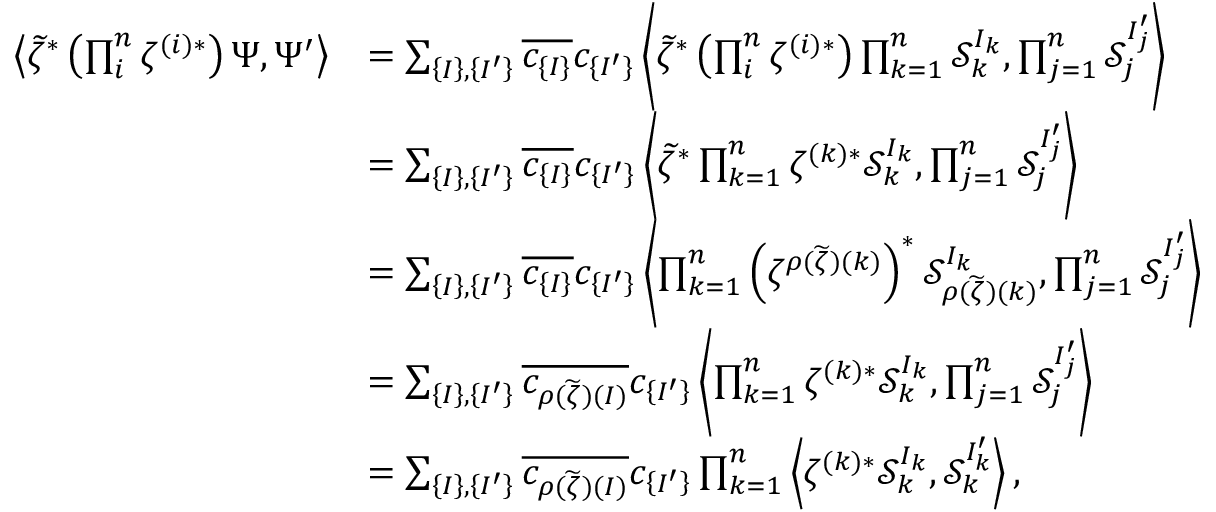Convert formula to latex. <formula><loc_0><loc_0><loc_500><loc_500>\begin{array} { r l } { \left < { \widetilde { \zeta } } ^ { * } \left ( \prod _ { i } ^ { n } \zeta ^ { ( i ) * } \right ) \Psi , \Psi ^ { \prime } \right > } & { = \sum _ { \left \{ I \right \} , \left \{ I ^ { \prime } \right \} } \overline { { c _ { \{ I \} } } } c _ { \{ I ^ { \prime } \} } \left < { \widetilde { \zeta } } ^ { * } \left ( \prod _ { i } ^ { n } \zeta ^ { ( i ) * } \right ) \prod _ { k = 1 } ^ { n } \mathcal { S } _ { k } ^ { I _ { k } } , \prod _ { j = 1 } ^ { n } \mathcal { S } _ { j } ^ { I _ { j } ^ { \prime } } \right > } \\ & { = \sum _ { \left \{ I \right \} , \left \{ I ^ { \prime } \right \} } \overline { { c _ { \left \{ I \right \} } } } c _ { \left \{ I ^ { \prime } \right \} } \left < \widetilde { \zeta } ^ { * } \prod _ { k = 1 } ^ { n } \zeta ^ { ( k ) * } \mathcal { S } _ { k } ^ { I _ { k } } , \prod _ { j = 1 } ^ { n } \mathcal { S } _ { j } ^ { I _ { j } ^ { \prime } } \right > } \\ & { = \sum _ { \left \{ I \right \} , \left \{ I ^ { \prime } \right \} } \overline { { c _ { \left \{ I \right \} } } } c _ { \left \{ I ^ { \prime } \right \} } \left < \prod _ { k = 1 } ^ { n } \left ( \zeta ^ { \rho ( \widetilde { \zeta } ) ( k ) } \right ) ^ { * } \mathcal { S } _ { \rho ( \widetilde { \zeta } ) ( k ) } ^ { I _ { k } } , \prod _ { j = 1 } ^ { n } \mathcal { S } _ { j } ^ { I _ { j } ^ { \prime } } \right > } \\ & { = \sum _ { \left \{ I \right \} , \left \{ I ^ { \prime } \right \} } \overline { { c _ { \rho ( \widetilde { \zeta } ) ( I ) } } } c _ { \left \{ I ^ { \prime } \right \} } \left < \prod _ { k = 1 } ^ { n } \zeta ^ { ( k ) * } { \mathcal { S } } _ { k } ^ { I _ { k } } , \prod _ { j = 1 } ^ { n } \mathcal { S } _ { j } ^ { I _ { j } ^ { \prime } } \right > } \\ & { = \sum _ { \left \{ I \right \} , \left \{ I ^ { \prime } \right \} } \overline { { c _ { \rho ( \widetilde { \zeta } ) ( I ) } } } c _ { \left \{ I ^ { \prime } \right \} } \prod _ { k = 1 } ^ { n } \left < \zeta ^ { ( k ) * } { \mathcal { S } } _ { k } ^ { I _ { k } } , \mathcal { S } _ { k } ^ { I _ { k } ^ { \prime } } \right > , } \end{array}</formula> 